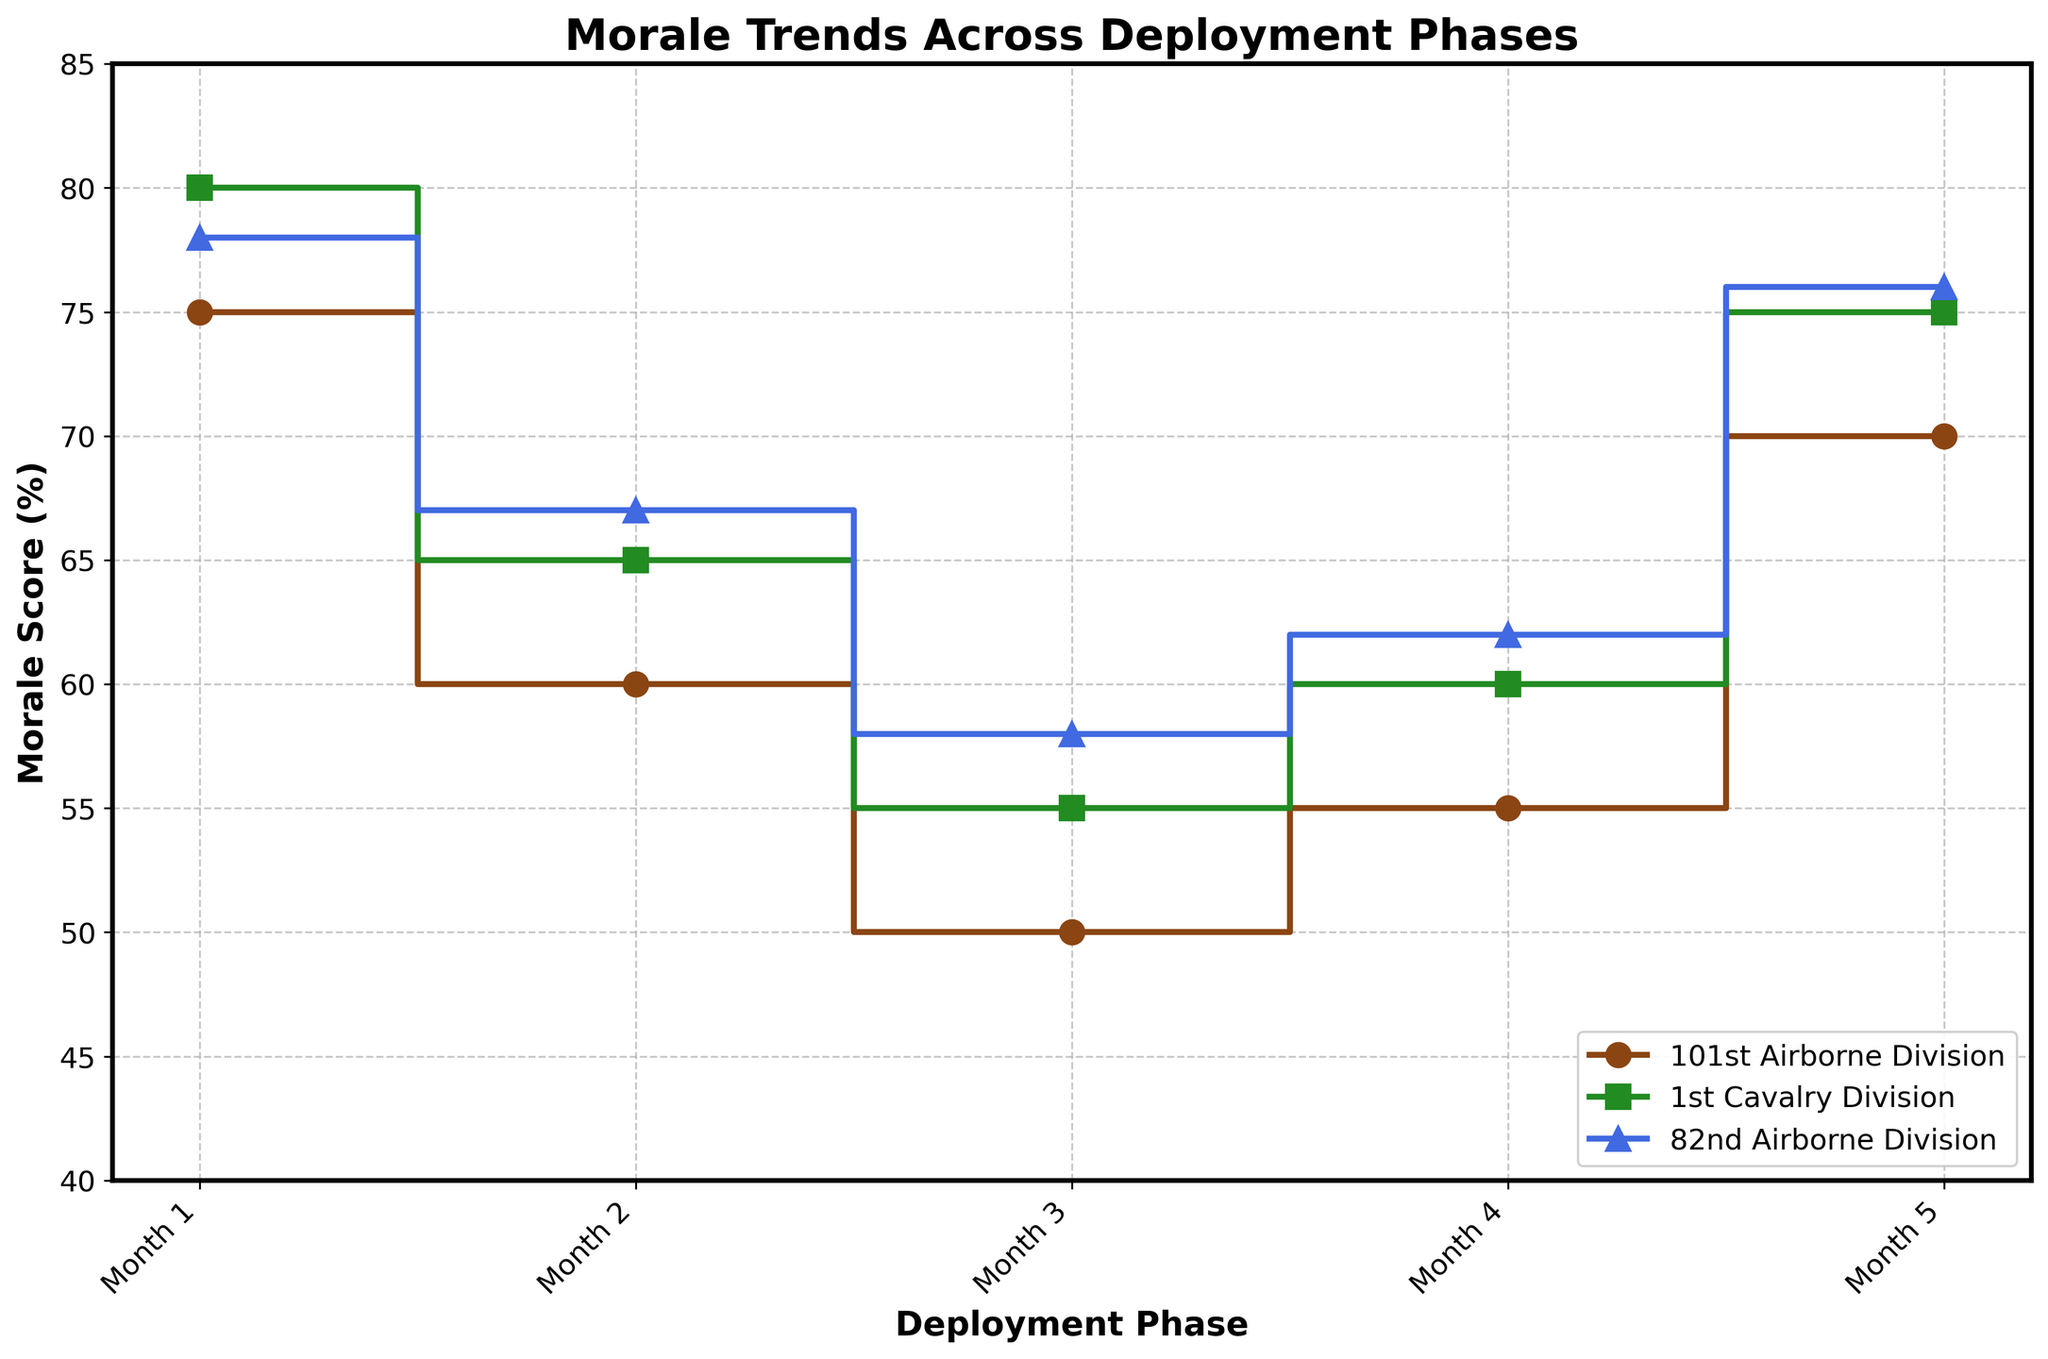What is the title of the plot? The title of the plot is prominently displayed above the chart. It helps to identify the main topic of the graph, which is essential for understanding the context of the data.
Answer: Morale Trends Across Deployment Phases What are the labels on the X and Y axes? The labels on the X and Y axes are essential for interpreting what data each axis represents. In this plot, the X-axis label gives us information about the timeline or categorization of the data, and the Y-axis label tells us what is being measured.
Answer: X: Deployment Phase, Y: Morale Score (%) Which unit had the highest morale score during the peak combat phase? To find the highest morale score during the peak combat phase, locate the data points for each unit at 'Month 3' and compare the values. The one with the highest percentage is the answer.
Answer: 82nd Airborne Division What was the morale score of the 101st Airborne Division during the drawdown phase? To find this information, locate the 'Month 5' data point for the 101st Airborne Division and read the corresponding morale score from the Y-axis.
Answer: 70% Which deployment phase shows the most significant drop in morale for the 1st Cavalry Division? To identify the phase with the most considerable decrease, look at the changes in morale scores between each consecutive month for the 1st Cavalry Division and find the largest drop.
Answer: Operational Buildup Compare the morale scores of the three units during the sustained operations phase. Which unit had the highest morale score? To answer this question, compare the data points for each unit at 'Month 4' and identify the unit with the highest morale score.
Answer: 82nd Airborne Division How does the morale score of the 101st Airborne Division change from the initial deployment to the drawdown phase? To determine the change, find the morale scores of the 101st Airborne Division at 'Month 1' and 'Month 5', and then calculate the difference.
Answer: Increases by 5% What is the average morale score of the 1st Cavalry Division over the five months? To compute the average morale score, sum up the morale percentages for each month and divide by the number of months (5).
Answer: 67% Which deployment phase showed the highest morale for the 82nd Airborne Division? To identify this, compare the morale scores at each deployment phase for the 82nd Airborne Division and determine the highest value.
Answer: Drawdown 